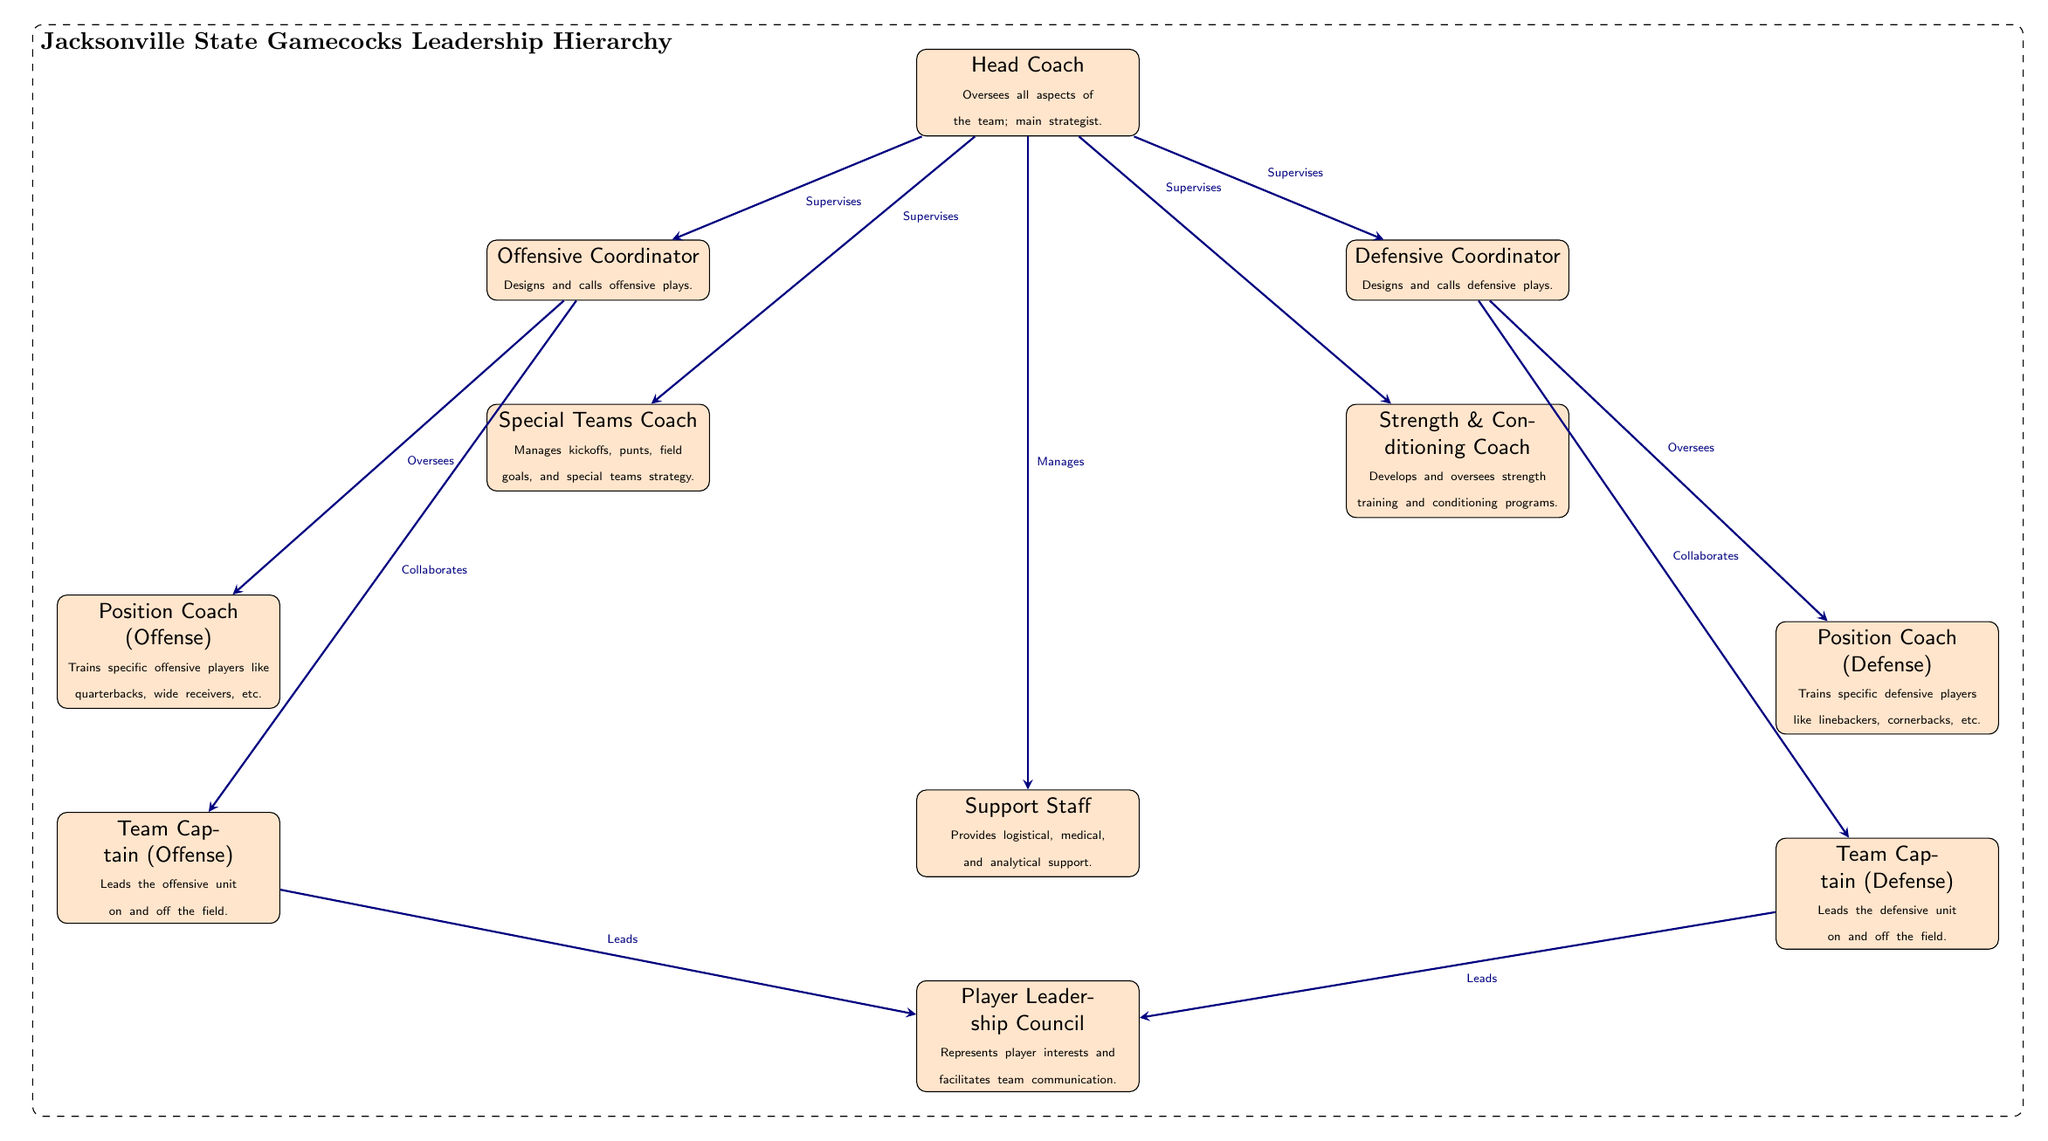What is the topmost position in the coaching hierarchy? The topmost position is indicated by the 'Head Coach' node in the diagram, which is placed at the top.
Answer: Head Coach How many coordinators are listed in the diagram? There are two coordinators shown in the diagram: Offensive Coordinator and Defensive Coordinator.
Answer: 2 Which role oversees the strength and conditioning coach? The diagram shows that the 'Head Coach' supervises the 'Strength & Conditioning Coach' as indicated by the arrow connecting the two nodes.
Answer: Head Coach What do the team captains lead? The 'Team Captains' (both offense and defense) lead the 'Player Leadership Council', as represented by the arrows pointing from each captain to the council node.
Answer: Player Leadership Council Who collaborates with the offensive coordinator? The 'Team Captain (Offense)' collaborates with the 'Offensive Coordinator', as evidenced by the directed edge connecting those two nodes in the diagram.
Answer: Team Captain (Offense) What type of support does the support staff provide? The support staff provides logistical, medical, and analytical support, which is described in the node for support staff.
Answer: Logistical, medical, and analytical support Which coaching position designs and calls defensive plays? In the diagram, the 'Defensive Coordinator' is responsible for designing and calling defensive plays, as denoted in the node's description.
Answer: Defensive Coordinator Where is the Player Leadership Council positioned in relation to the coaching staff? The Player Leadership Council is positioned below the coaching staff in the hierarchy, as indicated by its placement in the diagram, showing that it is influenced by the captains who lead it.
Answer: Below the coaching staff What does the arrow represent between the head coach and the support staff? The arrow indicates that the 'Head Coach' manages the 'Support Staff', illustrating the direct relationship of authority.
Answer: Manages 